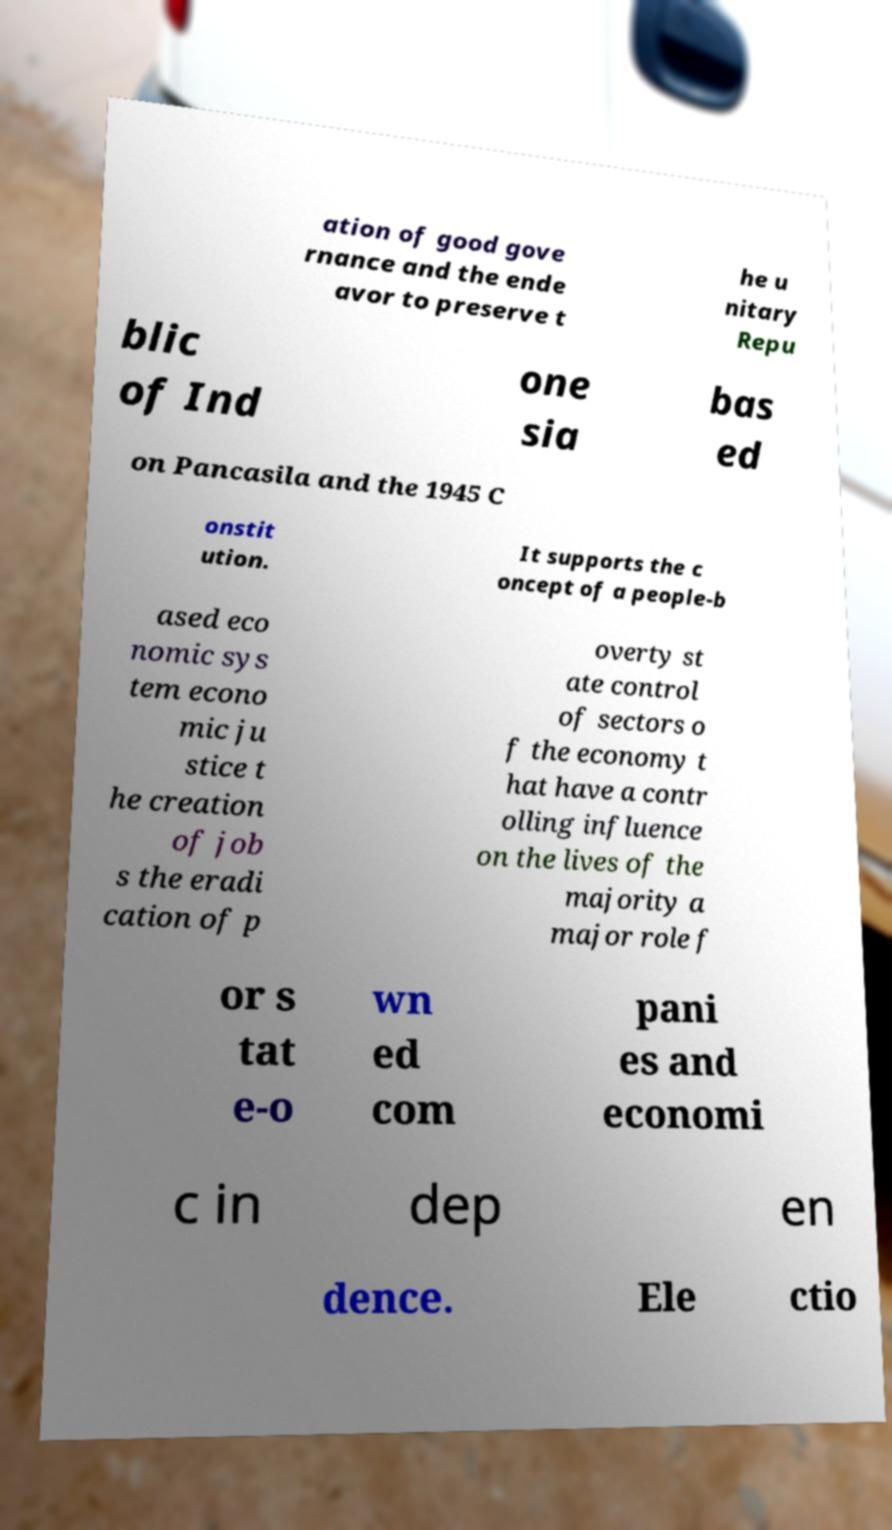Please read and relay the text visible in this image. What does it say? ation of good gove rnance and the ende avor to preserve t he u nitary Repu blic of Ind one sia bas ed on Pancasila and the 1945 C onstit ution. It supports the c oncept of a people-b ased eco nomic sys tem econo mic ju stice t he creation of job s the eradi cation of p overty st ate control of sectors o f the economy t hat have a contr olling influence on the lives of the majority a major role f or s tat e-o wn ed com pani es and economi c in dep en dence. Ele ctio 